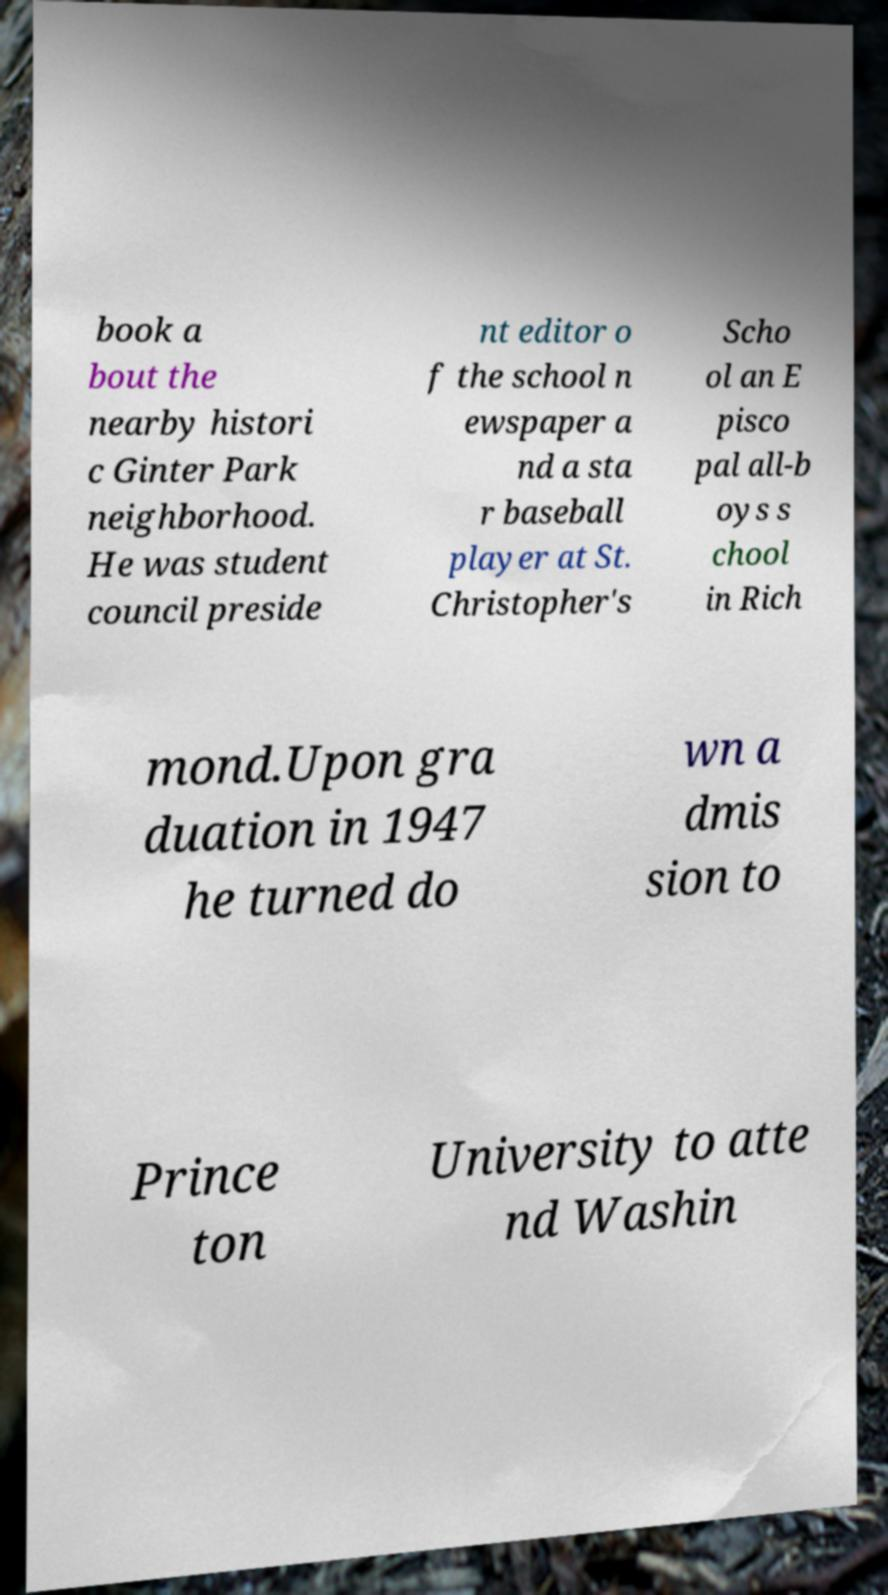Could you assist in decoding the text presented in this image and type it out clearly? book a bout the nearby histori c Ginter Park neighborhood. He was student council preside nt editor o f the school n ewspaper a nd a sta r baseball player at St. Christopher's Scho ol an E pisco pal all-b oys s chool in Rich mond.Upon gra duation in 1947 he turned do wn a dmis sion to Prince ton University to atte nd Washin 